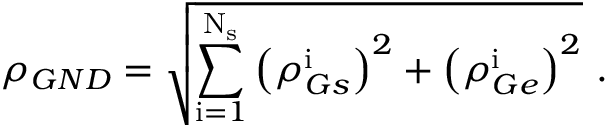Convert formula to latex. <formula><loc_0><loc_0><loc_500><loc_500>\rho _ { G N D } = \sqrt { \sum _ { i = 1 } ^ { N _ { s } } \left ( \rho _ { G s } ^ { i } \right ) ^ { 2 } + \left ( \rho _ { G e } ^ { i } \right ) ^ { 2 } } .</formula> 